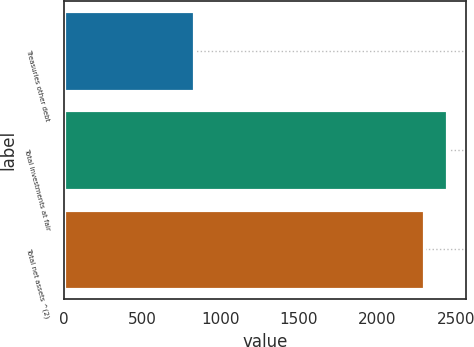<chart> <loc_0><loc_0><loc_500><loc_500><bar_chart><fcel>Treasuries other debt<fcel>Total investments at fair<fcel>Total net assets ^(2)<nl><fcel>830<fcel>2442.9<fcel>2296<nl></chart> 